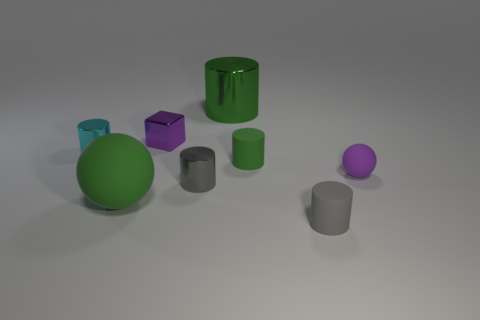How many gray cylinders must be subtracted to get 1 gray cylinders? 1 Add 1 metal cylinders. How many objects exist? 9 Subtract all gray rubber cylinders. How many cylinders are left? 4 Subtract 1 cyan cylinders. How many objects are left? 7 Subtract all spheres. How many objects are left? 6 Subtract 2 cylinders. How many cylinders are left? 3 Subtract all brown spheres. Subtract all yellow blocks. How many spheres are left? 2 Subtract all brown balls. How many gray cylinders are left? 2 Subtract all purple metal blocks. Subtract all cyan objects. How many objects are left? 6 Add 8 gray cylinders. How many gray cylinders are left? 10 